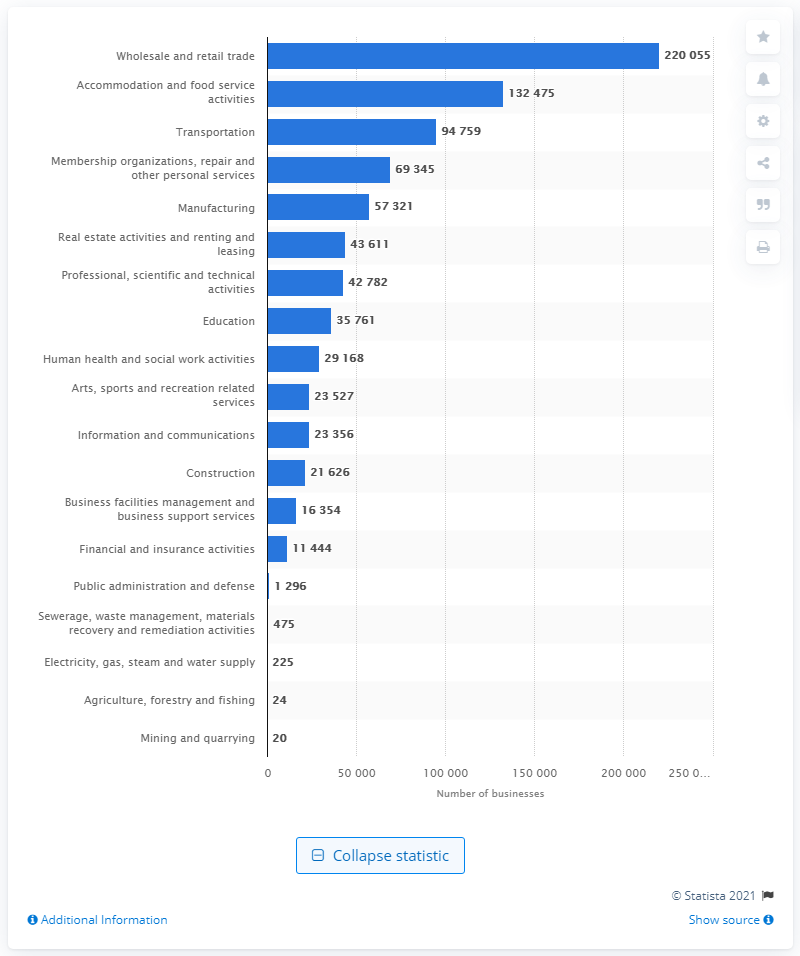Highlight a few significant elements in this photo. In 2019, there were approximately 220,055 businesses operating in Seoul. 